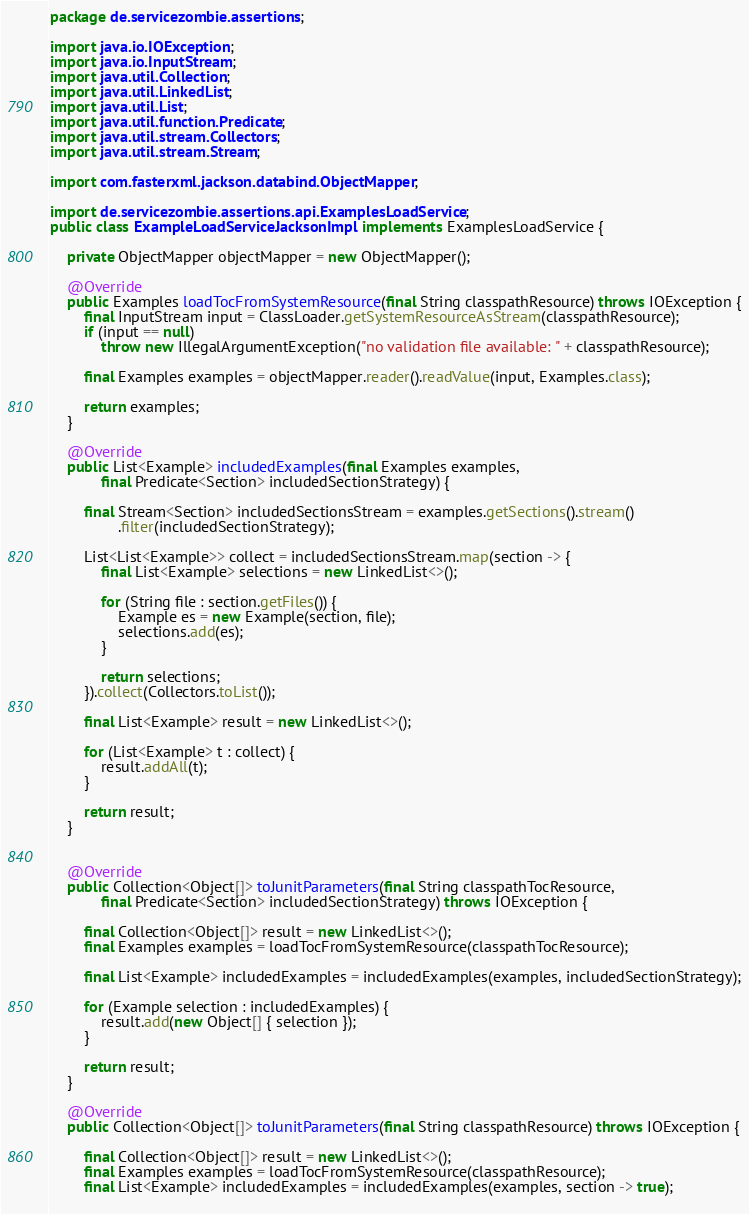<code> <loc_0><loc_0><loc_500><loc_500><_Java_>package de.servicezombie.assertions;

import java.io.IOException;
import java.io.InputStream;
import java.util.Collection;
import java.util.LinkedList;
import java.util.List;
import java.util.function.Predicate;
import java.util.stream.Collectors;
import java.util.stream.Stream;

import com.fasterxml.jackson.databind.ObjectMapper;

import de.servicezombie.assertions.api.ExamplesLoadService;
public class ExampleLoadServiceJacksonImpl implements ExamplesLoadService {

	private ObjectMapper objectMapper = new ObjectMapper();
	
	@Override
	public Examples loadTocFromSystemResource(final String classpathResource) throws IOException {
		final InputStream input = ClassLoader.getSystemResourceAsStream(classpathResource);
		if (input == null)
			throw new IllegalArgumentException("no validation file available: " + classpathResource);

		final Examples examples = objectMapper.reader().readValue(input, Examples.class);

		return examples;
	}

	@Override
	public List<Example> includedExamples(final Examples examples,
			final Predicate<Section> includedSectionStrategy) {

		final Stream<Section> includedSectionsStream = examples.getSections().stream()
				.filter(includedSectionStrategy);

		List<List<Example>> collect = includedSectionsStream.map(section -> {
			final List<Example> selections = new LinkedList<>();

			for (String file : section.getFiles()) {
				Example es = new Example(section, file);
				selections.add(es);
			}

			return selections;
		}).collect(Collectors.toList());

		final List<Example> result = new LinkedList<>();

		for (List<Example> t : collect) {
			result.addAll(t);
		}

		return result;
	}


	@Override
	public Collection<Object[]> toJunitParameters(final String classpathTocResource,
			final Predicate<Section> includedSectionStrategy) throws IOException {

		final Collection<Object[]> result = new LinkedList<>();
		final Examples examples = loadTocFromSystemResource(classpathTocResource);

		final List<Example> includedExamples = includedExamples(examples, includedSectionStrategy);

		for (Example selection : includedExamples) {
			result.add(new Object[] { selection });
		}

		return result;
	}

	@Override
	public Collection<Object[]> toJunitParameters(final String classpathResource) throws IOException {

		final Collection<Object[]> result = new LinkedList<>();
		final Examples examples = loadTocFromSystemResource(classpathResource);
		final List<Example> includedExamples = includedExamples(examples, section -> true);
		</code> 